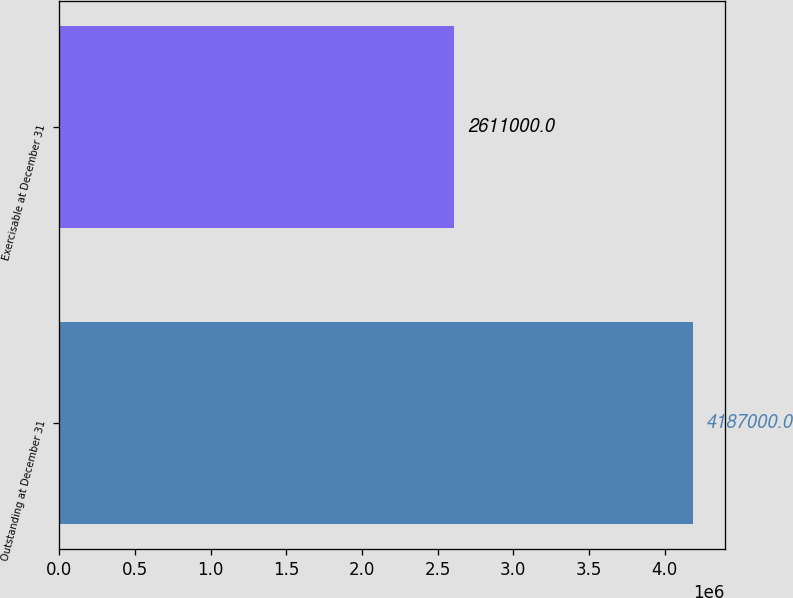<chart> <loc_0><loc_0><loc_500><loc_500><bar_chart><fcel>Outstanding at December 31<fcel>Exercisable at December 31<nl><fcel>4.187e+06<fcel>2.611e+06<nl></chart> 